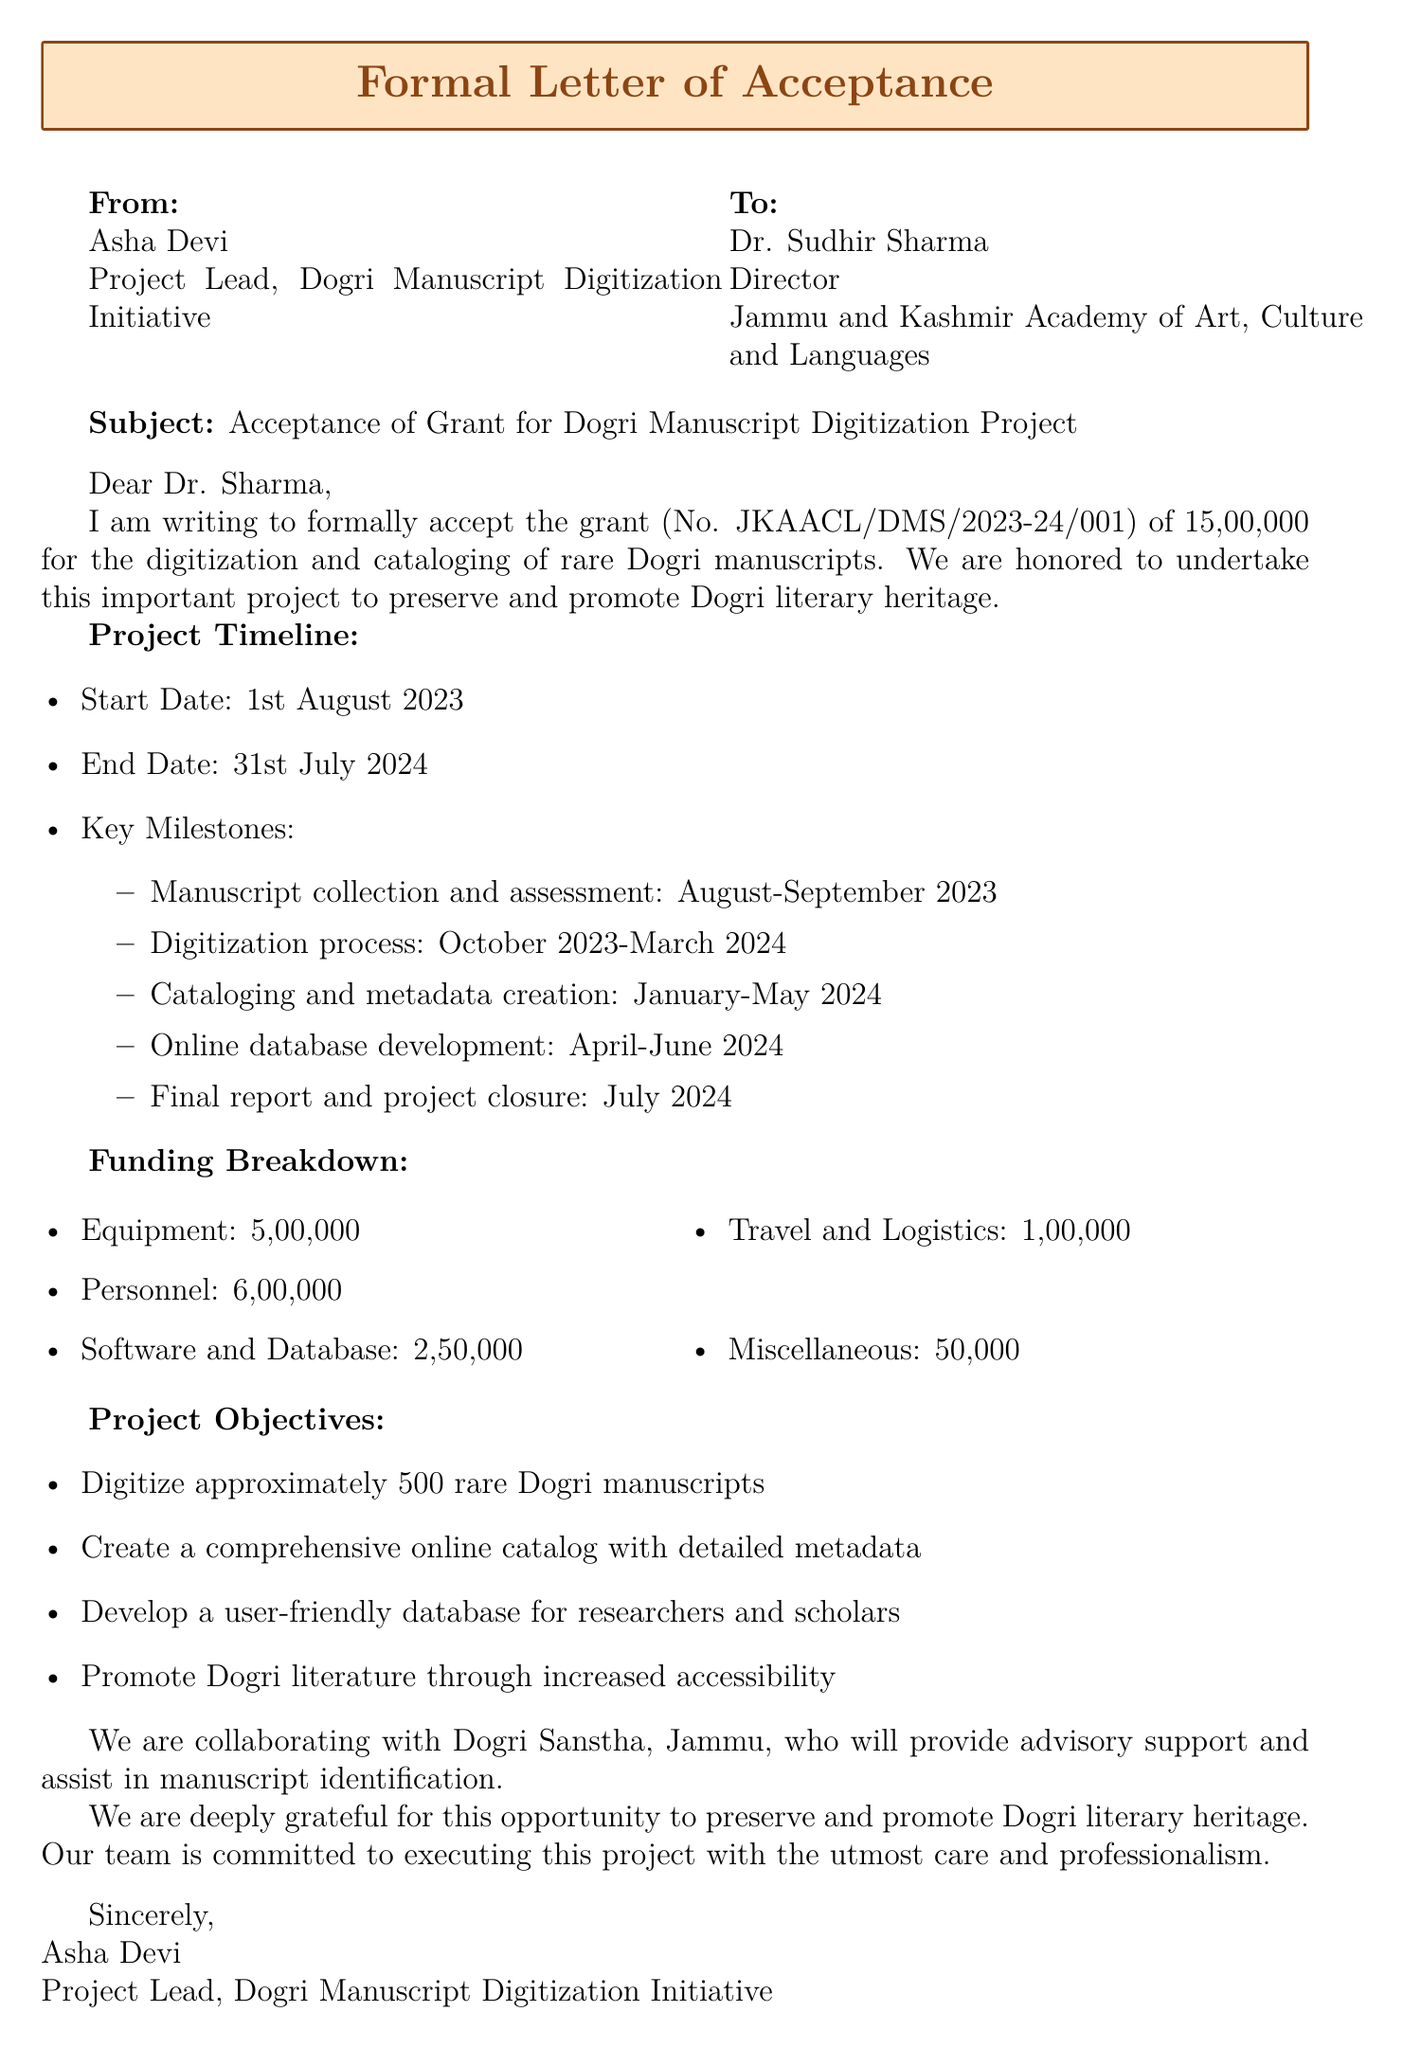What is the recipient's title? The title of the recipient, Dr. Sudhir Sharma, is mentioned in the document as "Director."
Answer: Director What is the grant amount? The document specifies that the grant amount accepted is ₹15,00,000.
Answer: ₹15,00,000 When does the project start? The document states that the project start date is 1st August 2023.
Answer: 1st August 2023 What is the total amount allocated for personnel? The funding breakdown shows that the amount for personnel is ₹6,00,000.
Answer: ₹6,00,000 What is one of the project objectives? The document lists objectives, including "Digitize approximately 500 rare Dogri manuscripts."
Answer: Digitize approximately 500 rare Dogri manuscripts What is the end date of the project? The end date for the project is outlined as 31st July 2024 in the document.
Answer: 31st July 2024 Which organization is collaborating on this project? The document mentions that the Dogri Sanstha, Jammu, is the collaborating organization.
Answer: Dogri Sanstha, Jammu What is the purpose of the grant? The purpose of the grant is specified as "Digitization and cataloging of rare Dogri manuscripts."
Answer: Digitization and cataloging of rare Dogri manuscripts When is the final report due? According to the timeline, the final report is due in July 2024.
Answer: July 2024 